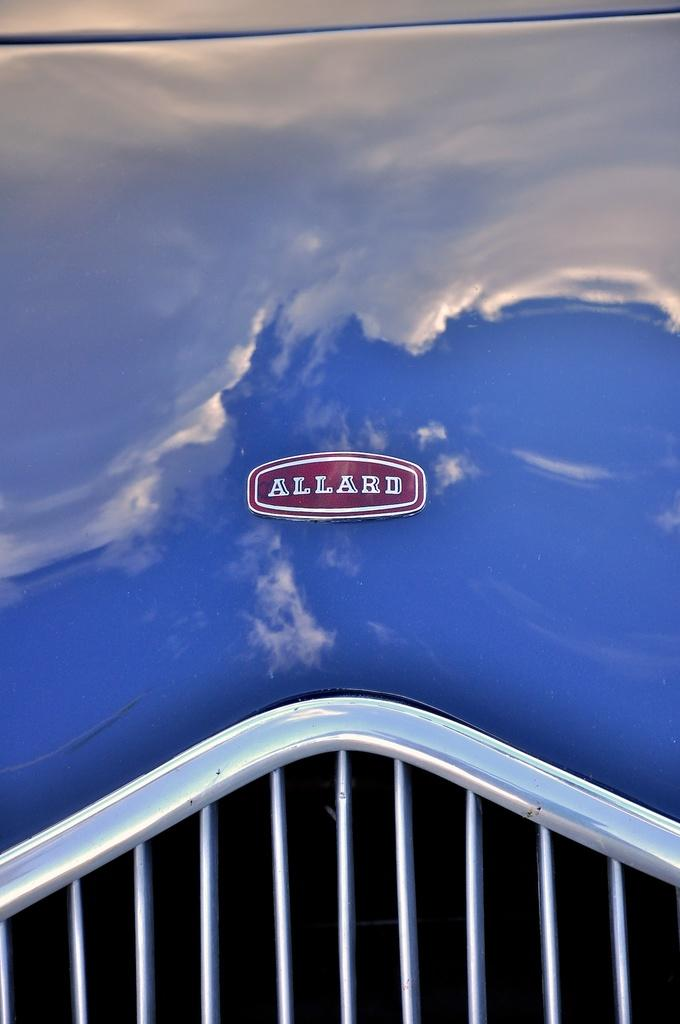What is the main subject of the image? The main subject of the image is a car. How is the car positioned in the image? The car is in the front view. What is the color of the car? The car is blue in color. Can you see any babies playing in the yard near the car in the image? There is no mention of a yard or a baby in the image; it only features a blue car in the front view. Is the car parked near the seashore in the image? There is no indication of a seashore in the image; it only features a blue car in the front view. 